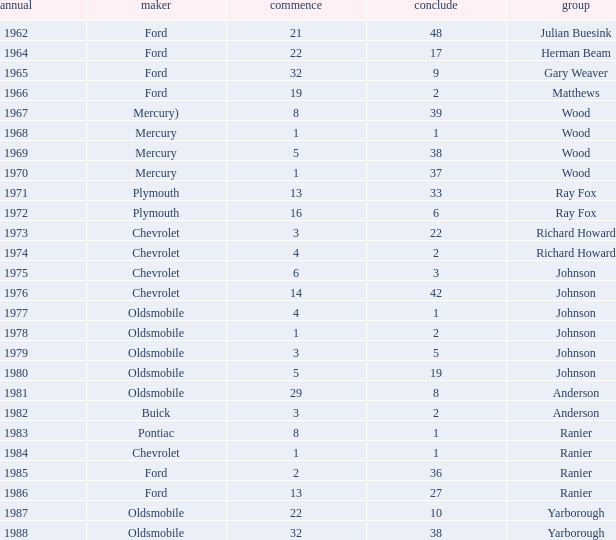What is the smallest finish time for a race where start was less than 3, buick was the manufacturer, and the race was held after 1978? None. 